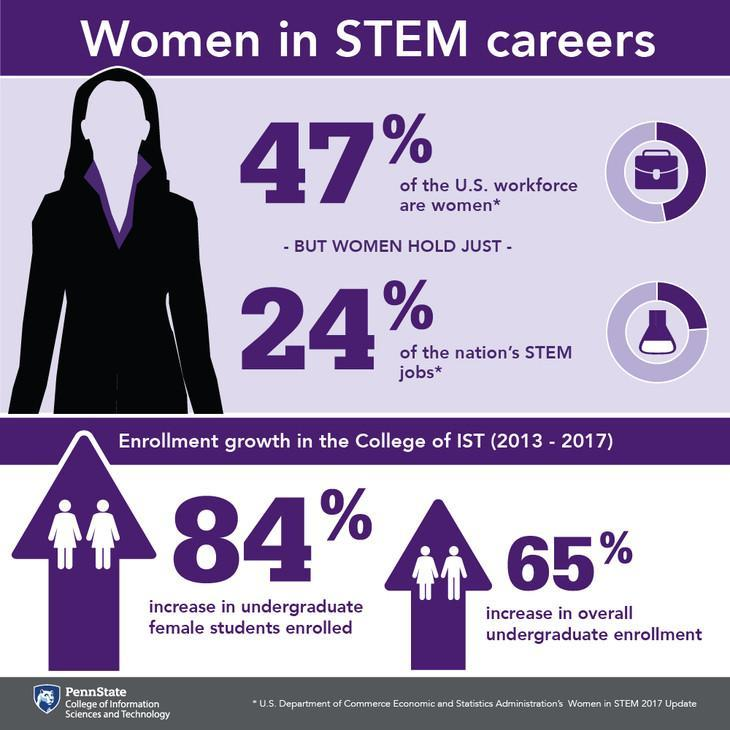What % of the US workforce are not women
Answer the question with a short phrase. 53 What % of the nations STEM jobs are not held by women 76 